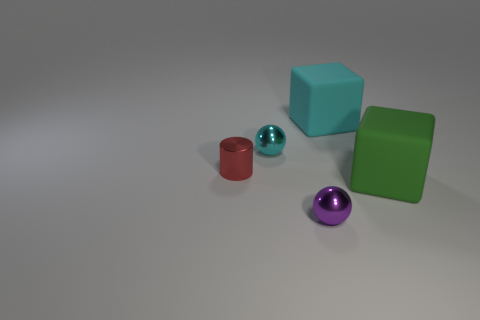The purple sphere has what size?
Ensure brevity in your answer.  Small. What number of spheres have the same color as the cylinder?
Give a very brief answer. 0. Are there any large cubes behind the rubber cube that is behind the rubber cube that is in front of the red shiny cylinder?
Make the answer very short. No. There is a red metal thing that is the same size as the cyan sphere; what is its shape?
Your response must be concise. Cylinder. What number of big things are either green blocks or brown cylinders?
Your response must be concise. 1. What is the color of the ball that is the same material as the purple thing?
Provide a short and direct response. Cyan. There is a large rubber thing that is behind the red metal thing; does it have the same shape as the big green rubber object that is behind the small purple shiny sphere?
Offer a terse response. Yes. What number of rubber things are either large gray blocks or tiny red objects?
Your response must be concise. 0. Are there any other things that have the same shape as the tiny red thing?
Your answer should be very brief. No. What is the material of the cyan thing that is on the right side of the purple metallic sphere?
Offer a very short reply. Rubber. 